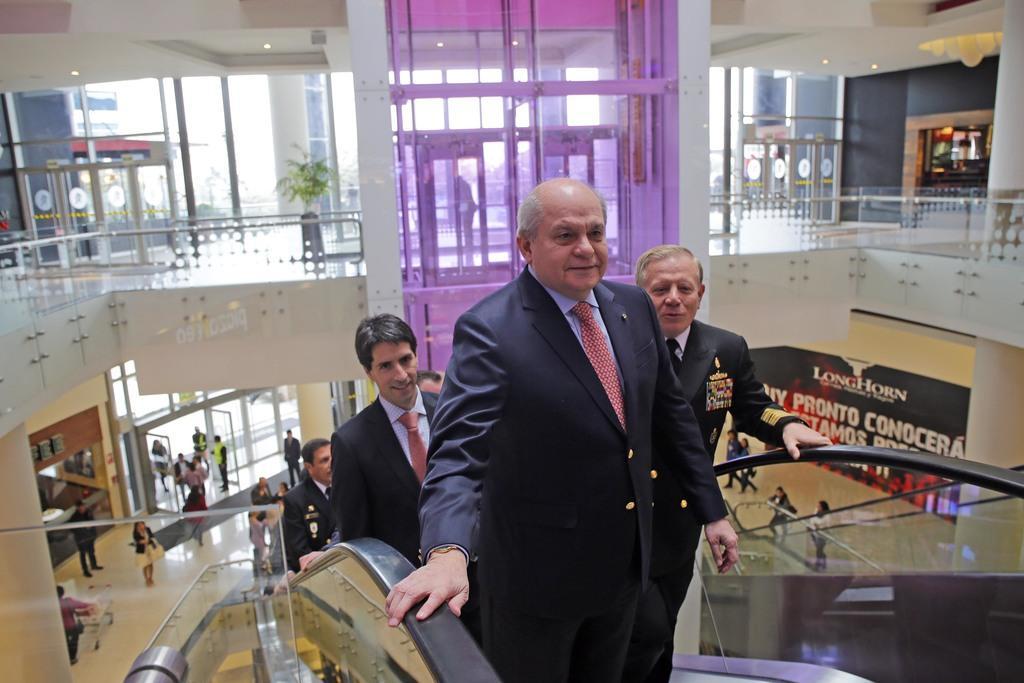Describe this image in one or two sentences. In the image few people are standing on a escalator. Behind them there is a wall and fencing and there are some plants. Bottom left side of the image few people are standing and walking and there is a glass door. Bottom right side of the image there is a banner and few few people are standing and walking. 